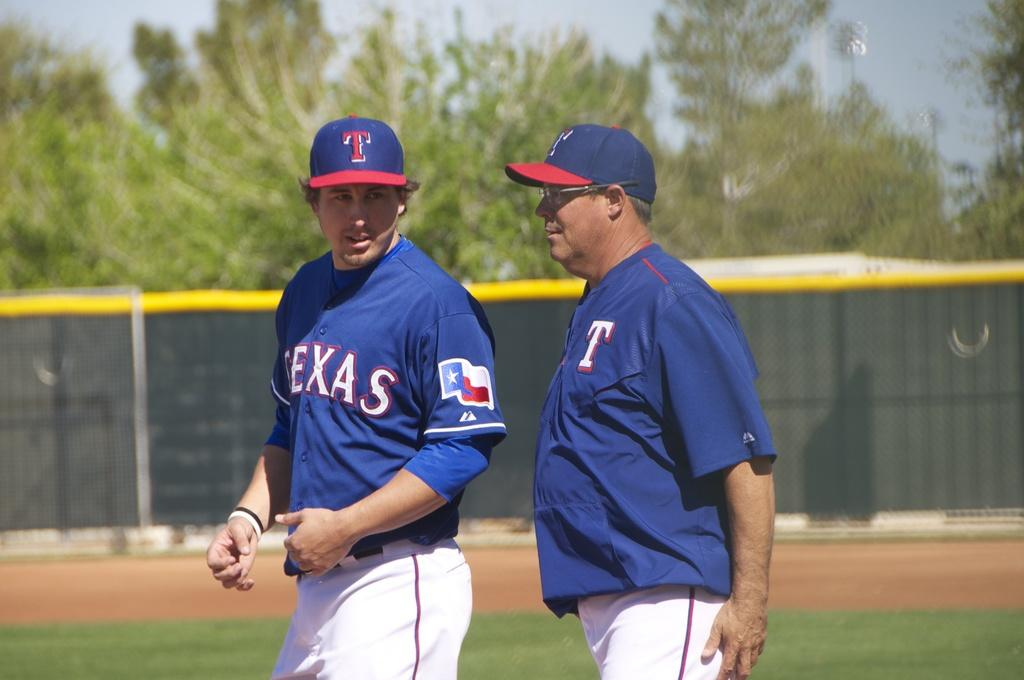<image>
Create a compact narrative representing the image presented. the name Texas that is on a jersey 